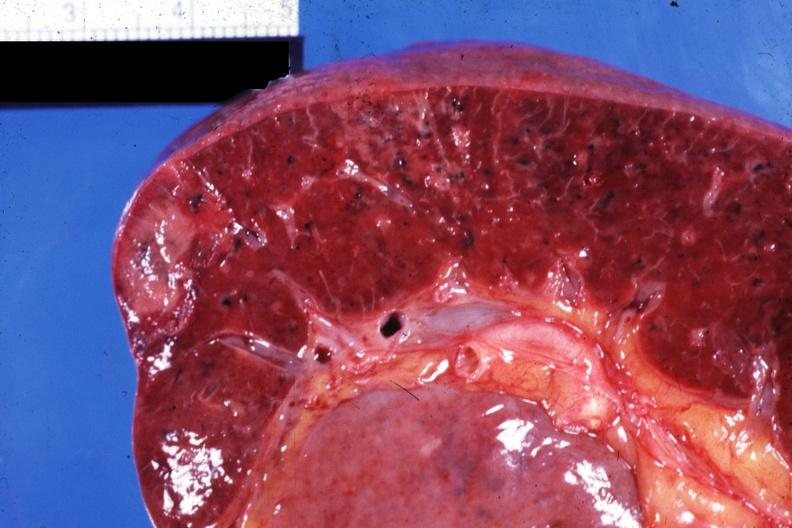s hematologic present?
Answer the question using a single word or phrase. Yes 